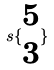Convert formula to latex. <formula><loc_0><loc_0><loc_500><loc_500>s \{ \begin{matrix} 5 \\ 3 \end{matrix} \}</formula> 